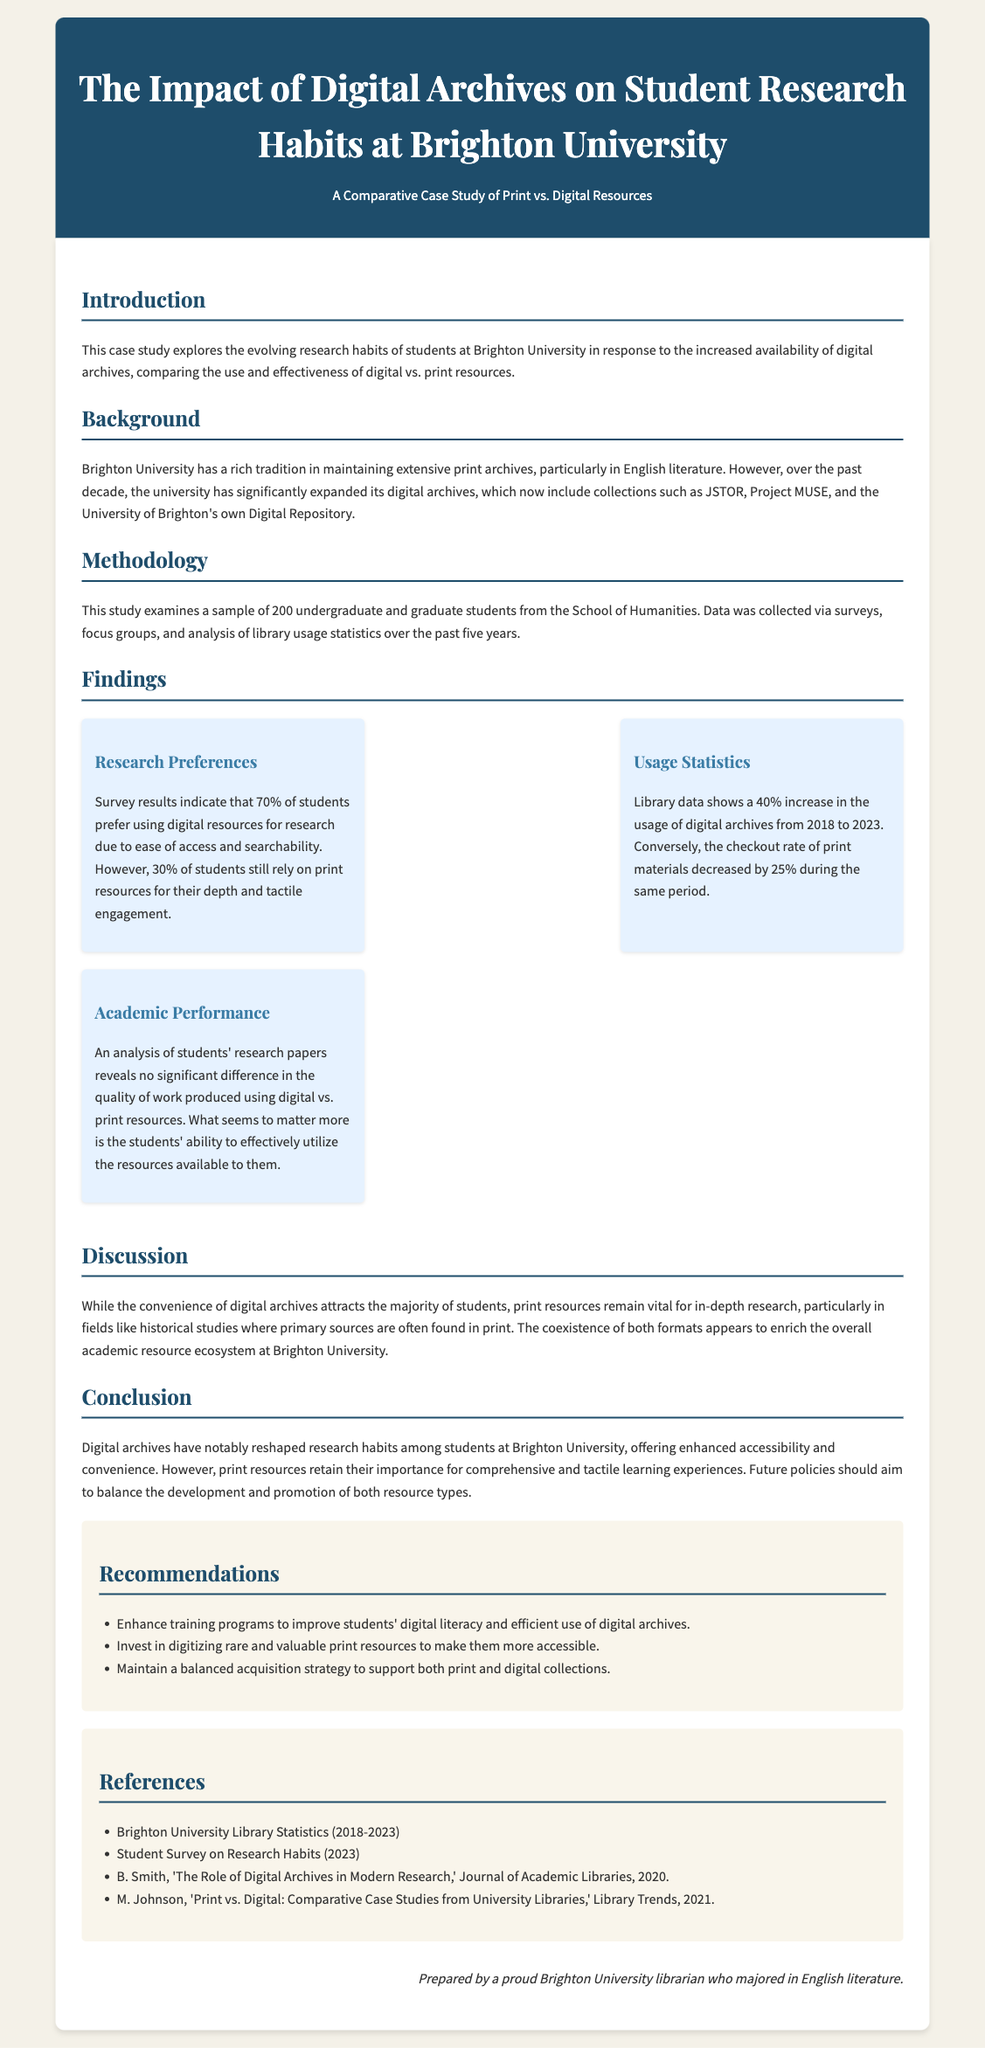what is the sample size of students in this study? The case study examines a sample of 200 undergraduate and graduate students.
Answer: 200 what is the percentage of students preferring digital resources? Survey results indicate that 70% of students prefer using digital resources for research.
Answer: 70% how much did the usage of digital archives increase from 2018 to 2023? Library data shows a 40% increase in the usage of digital archives during this period.
Answer: 40% what should be enhanced according to the recommendations? The recommendations suggest enhancing training programs to improve students' digital literacy.
Answer: training programs what is the overall conclusion about digital archives? The conclusion states that digital archives have reshaped research habits among students, while print resources retain importance.
Answer: reshaped research habits how much did the checkout rate of print materials decrease? The checkout rate of print materials decreased by 25% during the same period.
Answer: 25% what kind of analysis was conducted on students' research papers? An analysis of students' research papers reveals no significant difference in the quality of work produced.
Answer: analysis who authored the reference titled 'The Role of Digital Archives in Modern Research'? The reference is authored by B. Smith.
Answer: B. Smith what type of study is this document presenting? The document presents a case study comparing the use of digital vs. print resources.
Answer: case study 